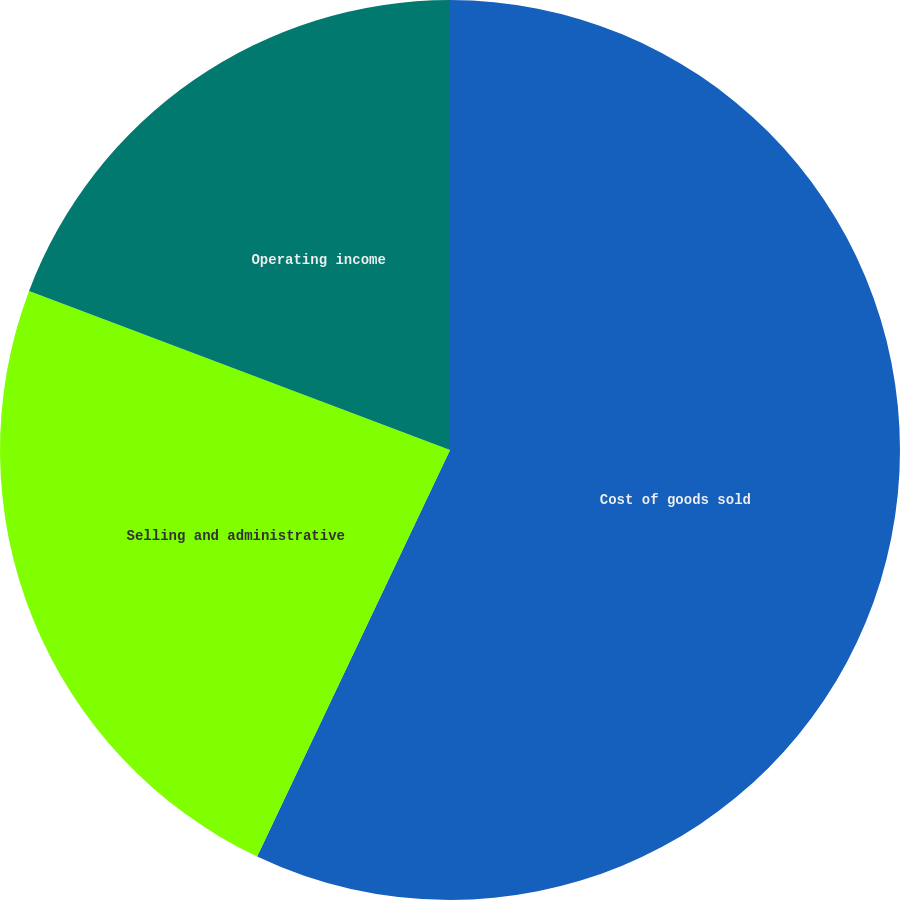<chart> <loc_0><loc_0><loc_500><loc_500><pie_chart><fcel>Cost of goods sold<fcel>Selling and administrative<fcel>Operating income<nl><fcel>57.05%<fcel>23.7%<fcel>19.25%<nl></chart> 